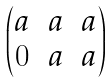<formula> <loc_0><loc_0><loc_500><loc_500>\begin{pmatrix} a & a & a \\ 0 & a & a \\ \end{pmatrix}</formula> 